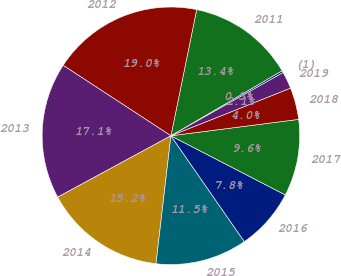Convert chart to OTSL. <chart><loc_0><loc_0><loc_500><loc_500><pie_chart><fcel>(1)<fcel>2011<fcel>2012<fcel>2013<fcel>2014<fcel>2015<fcel>2016<fcel>2017<fcel>2018<fcel>2019<nl><fcel>0.26%<fcel>13.37%<fcel>18.99%<fcel>17.12%<fcel>15.25%<fcel>11.5%<fcel>7.75%<fcel>9.63%<fcel>4.0%<fcel>2.13%<nl></chart> 